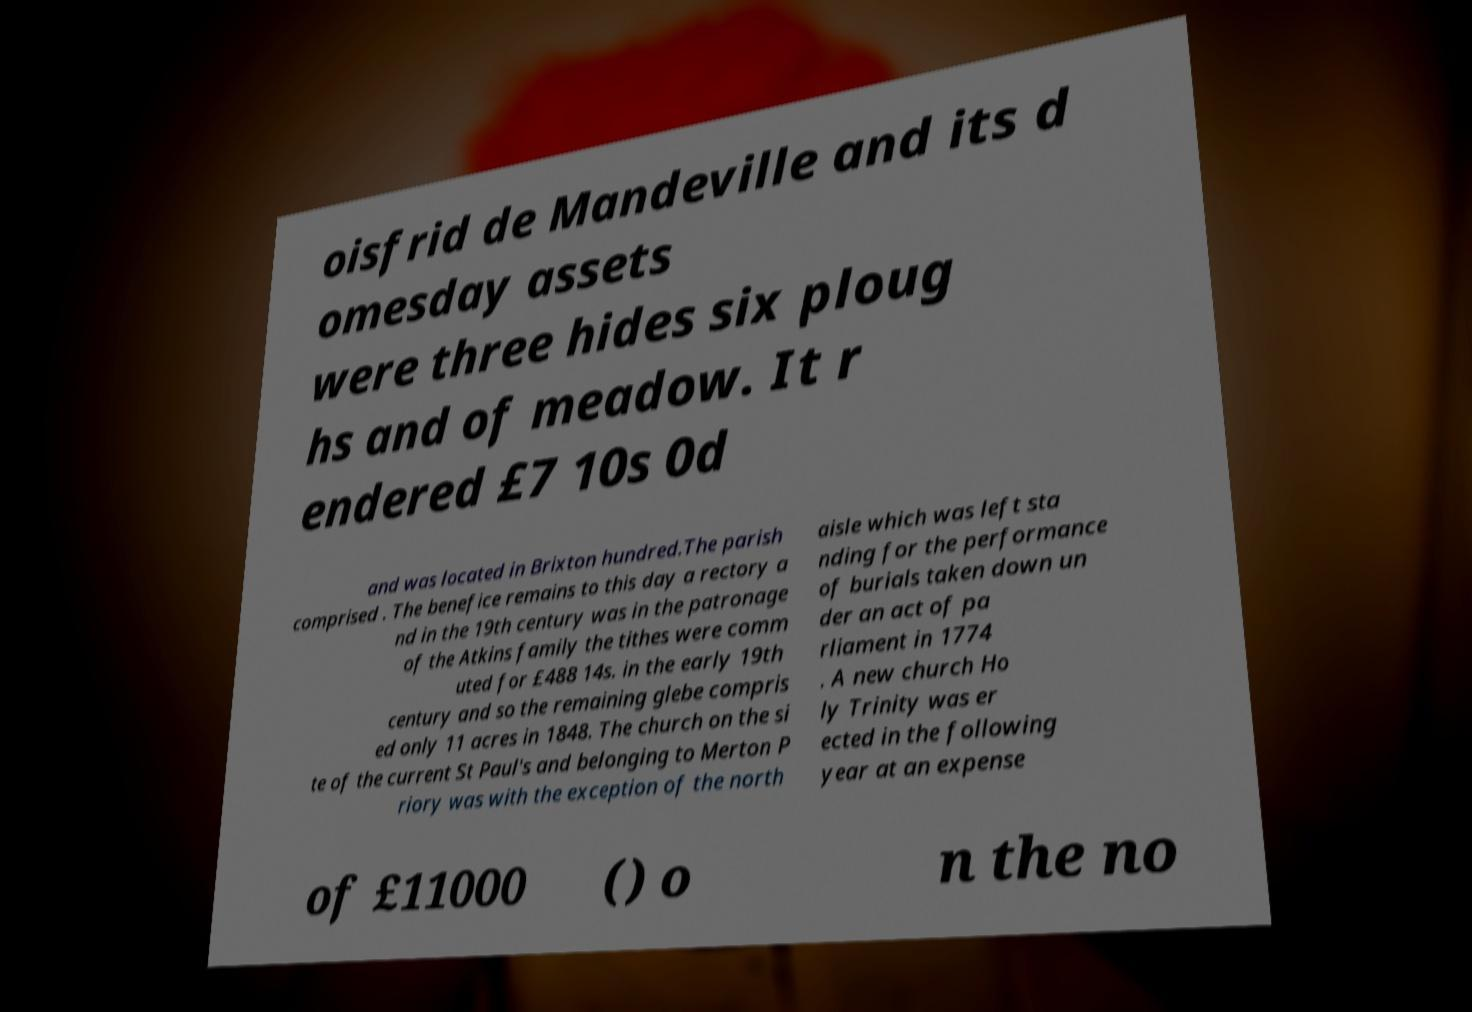Please read and relay the text visible in this image. What does it say? oisfrid de Mandeville and its d omesday assets were three hides six ploug hs and of meadow. It r endered £7 10s 0d and was located in Brixton hundred.The parish comprised . The benefice remains to this day a rectory a nd in the 19th century was in the patronage of the Atkins family the tithes were comm uted for £488 14s. in the early 19th century and so the remaining glebe compris ed only 11 acres in 1848. The church on the si te of the current St Paul's and belonging to Merton P riory was with the exception of the north aisle which was left sta nding for the performance of burials taken down un der an act of pa rliament in 1774 . A new church Ho ly Trinity was er ected in the following year at an expense of £11000 () o n the no 